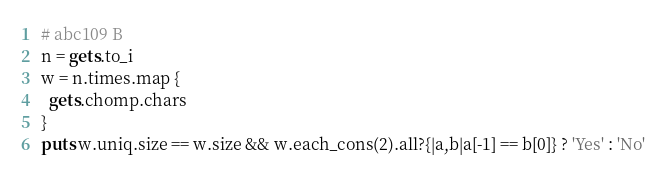Convert code to text. <code><loc_0><loc_0><loc_500><loc_500><_Ruby_># abc109 B
n = gets.to_i
w = n.times.map {
  gets.chomp.chars
}
puts w.uniq.size == w.size && w.each_cons(2).all?{|a,b|a[-1] == b[0]} ? 'Yes' : 'No'

</code> 